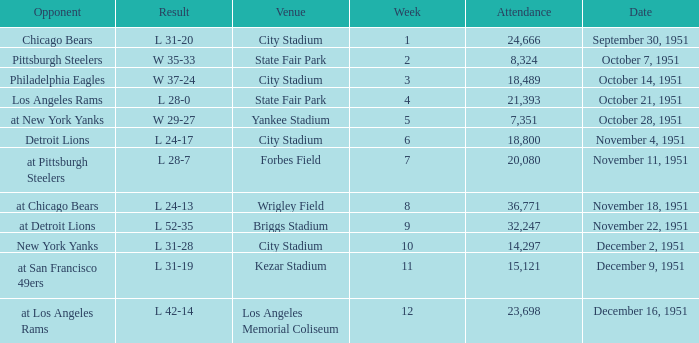Which venue hosted the Los Angeles Rams as an opponent? State Fair Park. 